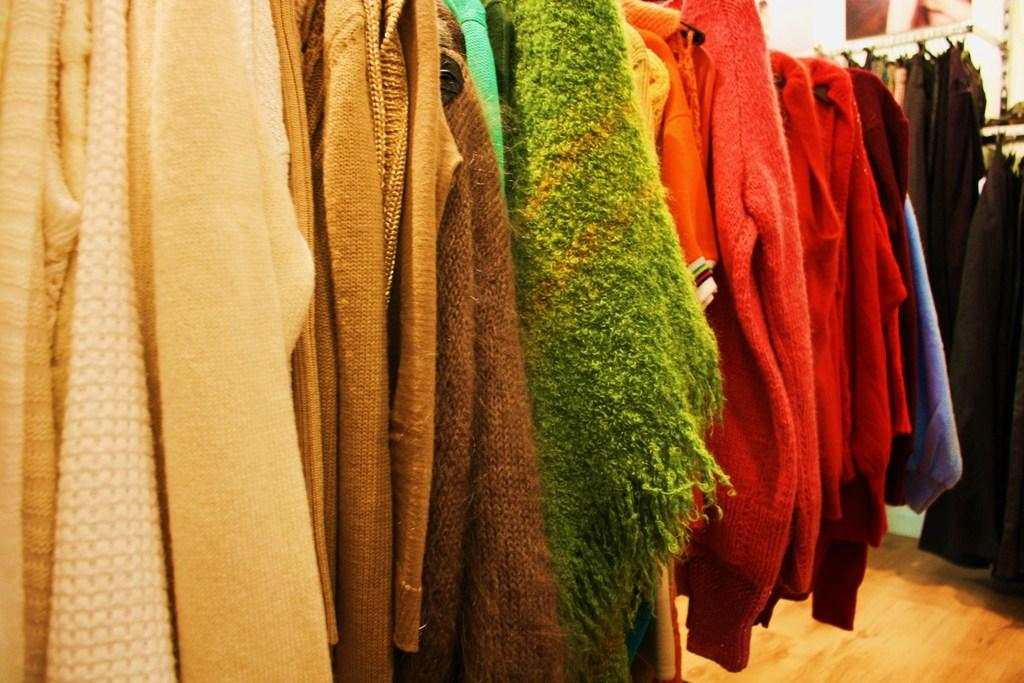What is the primary surface visible in the image? The image contains the floor. What type of objects can be seen on the floor in the image? There are clothes visible on the floor in the image. What is present on the wall in the background of the image? There is a photo on the wall in the background of the image. What type of bridge can be seen connecting the clothes in the image? There is no bridge present in the image; it features clothes on the floor and a photo on the wall. What type of brass instrument is visible in the image? There is no brass instrument present in the image. 